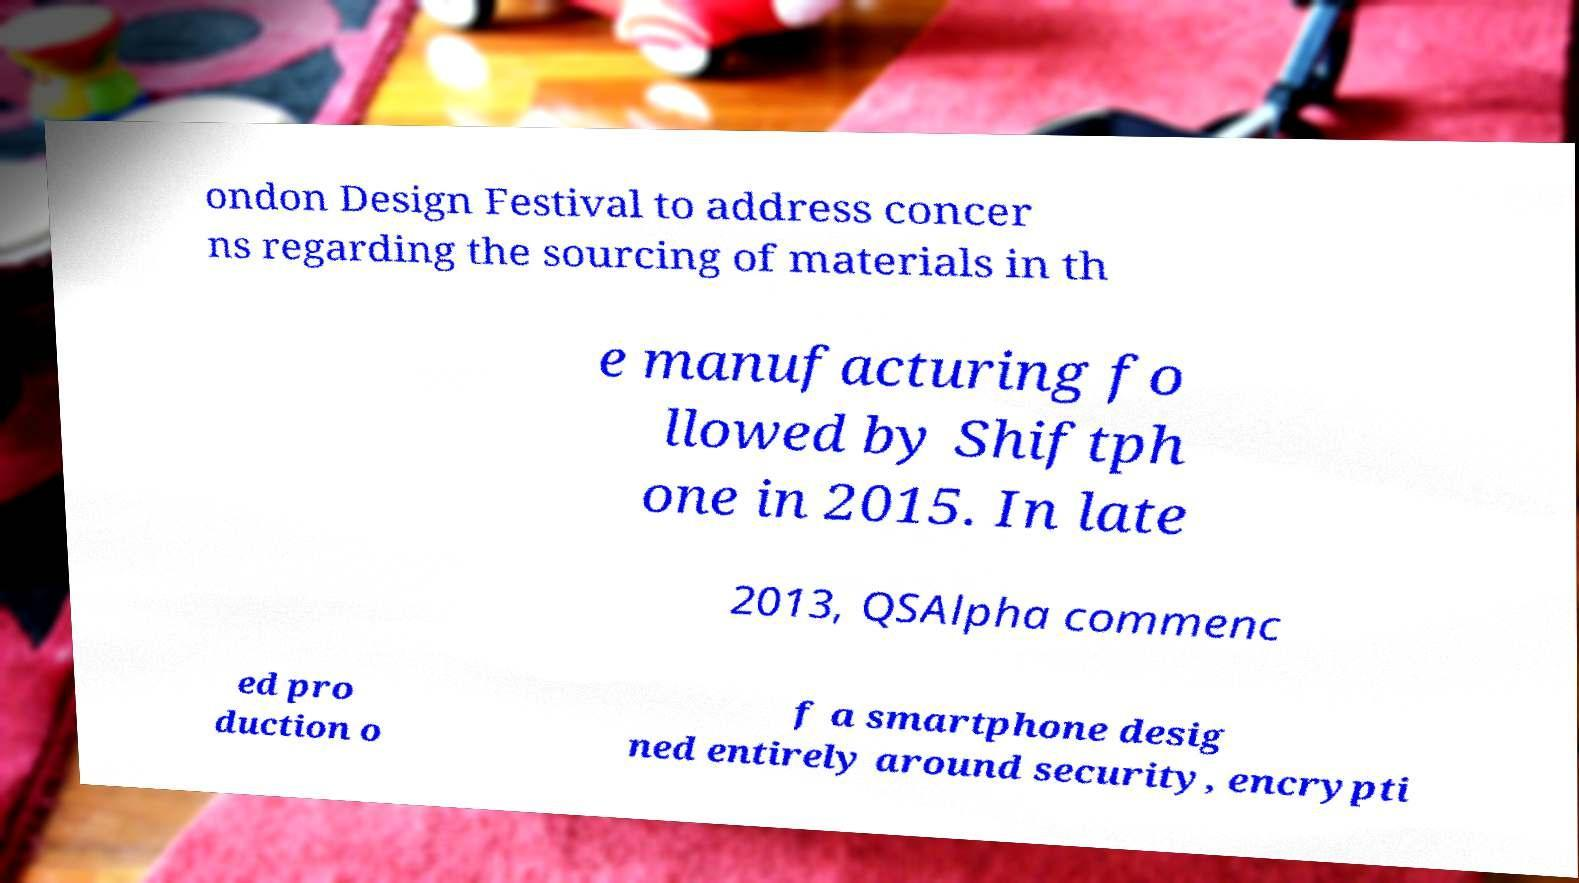I need the written content from this picture converted into text. Can you do that? ondon Design Festival to address concer ns regarding the sourcing of materials in th e manufacturing fo llowed by Shiftph one in 2015. In late 2013, QSAlpha commenc ed pro duction o f a smartphone desig ned entirely around security, encrypti 